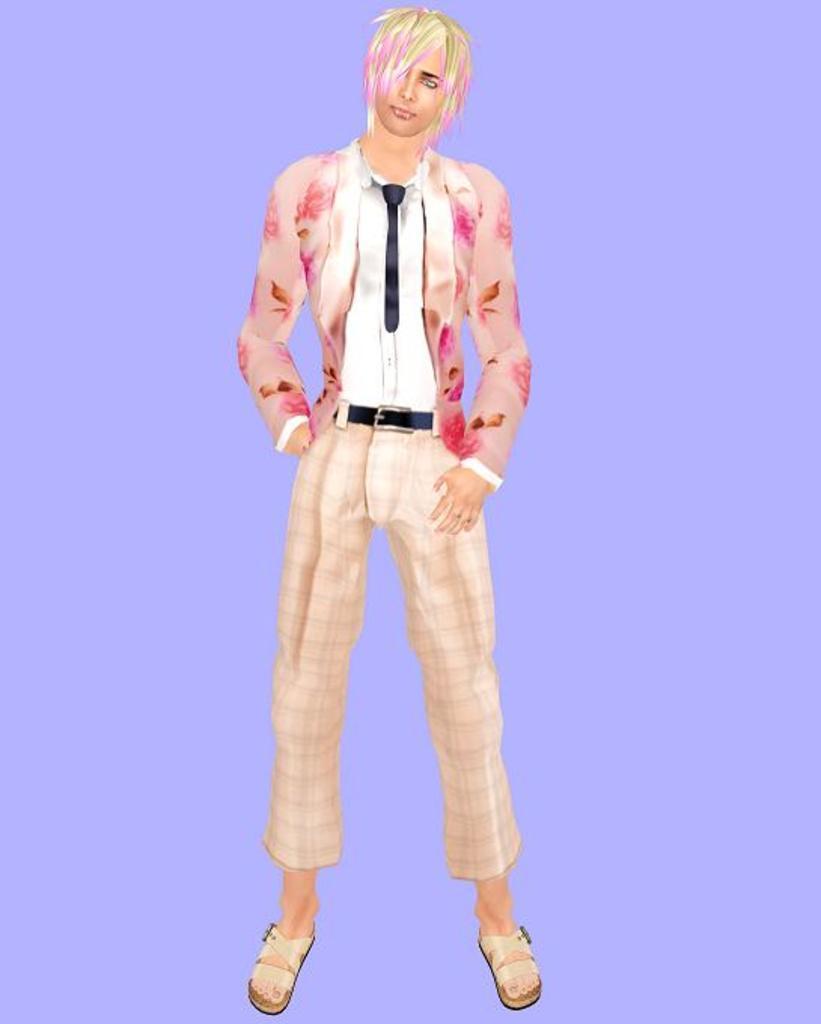Describe this image in one or two sentences. In this picture we can see an animated person and behind the person there is a purple background. 